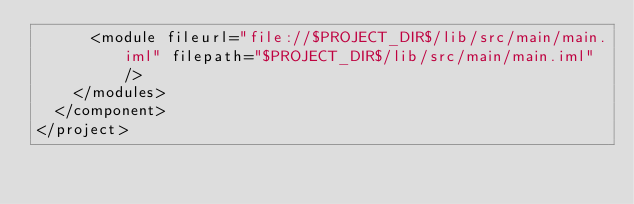<code> <loc_0><loc_0><loc_500><loc_500><_XML_>      <module fileurl="file://$PROJECT_DIR$/lib/src/main/main.iml" filepath="$PROJECT_DIR$/lib/src/main/main.iml" />
    </modules>
  </component>
</project></code> 